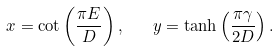<formula> <loc_0><loc_0><loc_500><loc_500>x = \cot \left ( \frac { \pi E } { D } \right ) , \quad y = \tanh \left ( \frac { \pi \gamma } { 2 D } \right ) .</formula> 